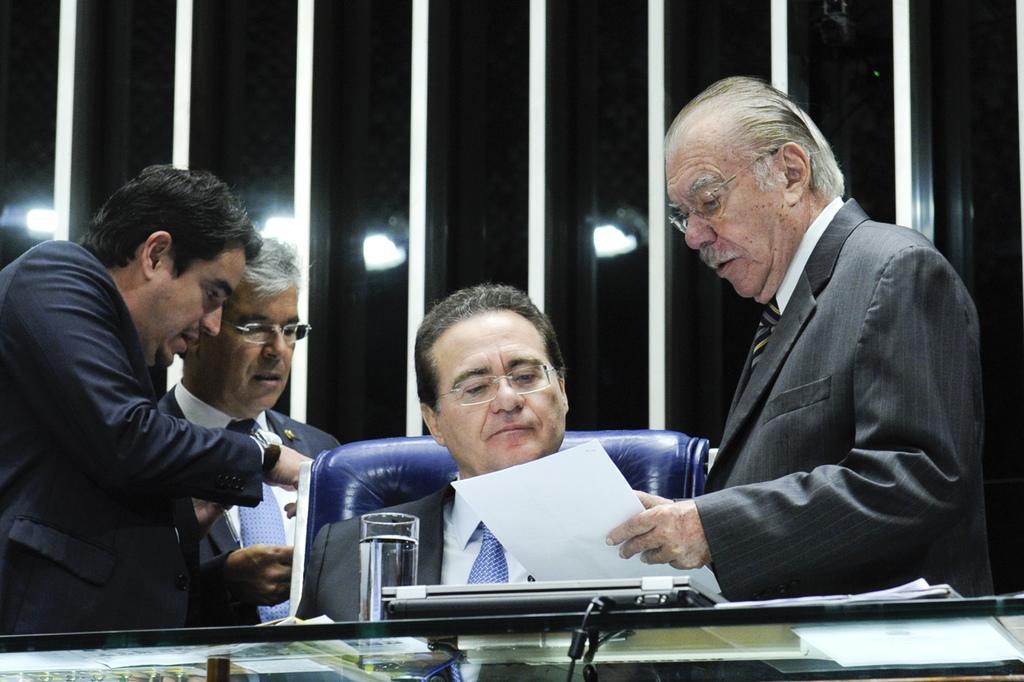Can you describe this image briefly? In this image I can see four persons two are sitting and two are standing. The person in front wearing gray color blazer, white color shirt and holding few papers, in front I can see a glass and a laptop. Background I can see few lights. 